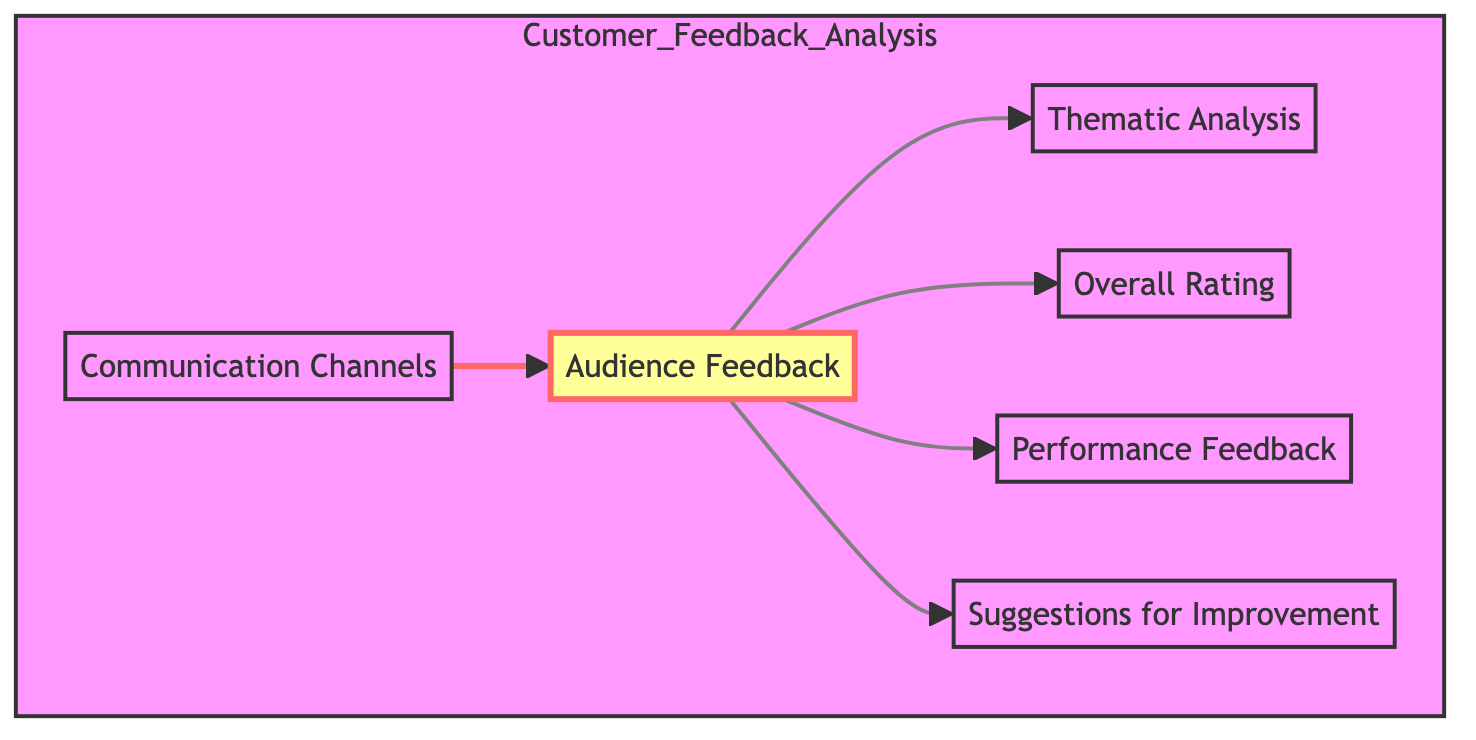What is the main element that collects impressions from viewers? The main element for collecting impressions from viewers is "Audience Feedback," which is represented as the root node in the diagram. The diagram indicates that audience feedback is the starting point for analyzing customer feedback.
Answer: Audience Feedback How many feedback types are connected to Audience Feedback? The diagram shows four feedback types directly connected to "Audience Feedback," which include Thematic Analysis, Overall Rating, Performance Feedback, and Suggestions for Improvement. Counting these gives a total of four direct connections.
Answer: 4 What type of analysis identifies recurring themes? The type of analysis that identifies recurring themes from audience feedback is "Thematic Analysis." This node is connected to the "Audience Feedback" node in the flowchart.
Answer: Thematic Analysis Which node is a method for gathering feedback? The node that represents a method for gathering feedback is "Communication Channels." This is a distinct element that channels the feedback into the analysis process.
Answer: Communication Channels What is the relationship between Audience Feedback and Overall Rating? The relationship is that "Audience Feedback" is the source that feeds into "Overall Rating." This indicates that the average rating is derived from the feedback collected from the audience.
Answer: Audience Feedback feeds into Overall Rating How does Suggestions for Improvement relate to Audience Feedback? "Suggestions for Improvement" is one of the outputs from "Audience Feedback," meaning it is generated based on the responses received from the audience's initial feedback. The feedback informs possible enhancements for future productions.
Answer: Suggestions for Improvement is an output of Audience Feedback What is the function of Performance Feedback in this analysis? The function of "Performance Feedback" is to provide specific comments on acting, direction, and stage presence. It directly connects to "Audience Feedback," indicating that it is part of the feedback derived from audience impressions.
Answer: Specific comments on acting, direction, and stage presence How many nodes are there in total in the diagram? The total number of nodes in the diagram consists of one root node, "Audience Feedback," and five additional connected nodes, resulting in a total of six nodes.
Answer: 6 Which element involves gathering feedback through online surveys? The element that involves gathering feedback through online surveys is "Communication Channels," as it encompasses various methods for feedback collection, including surveys and social media.
Answer: Communication Channels 